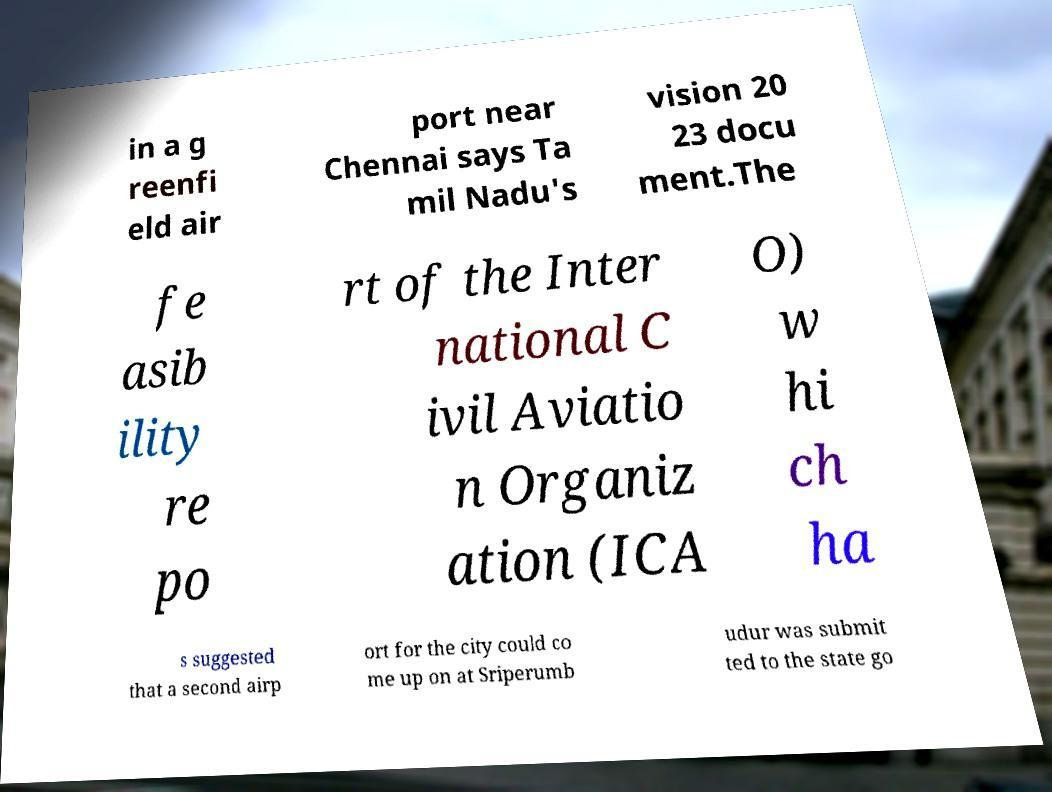Can you accurately transcribe the text from the provided image for me? in a g reenfi eld air port near Chennai says Ta mil Nadu's vision 20 23 docu ment.The fe asib ility re po rt of the Inter national C ivil Aviatio n Organiz ation (ICA O) w hi ch ha s suggested that a second airp ort for the city could co me up on at Sriperumb udur was submit ted to the state go 